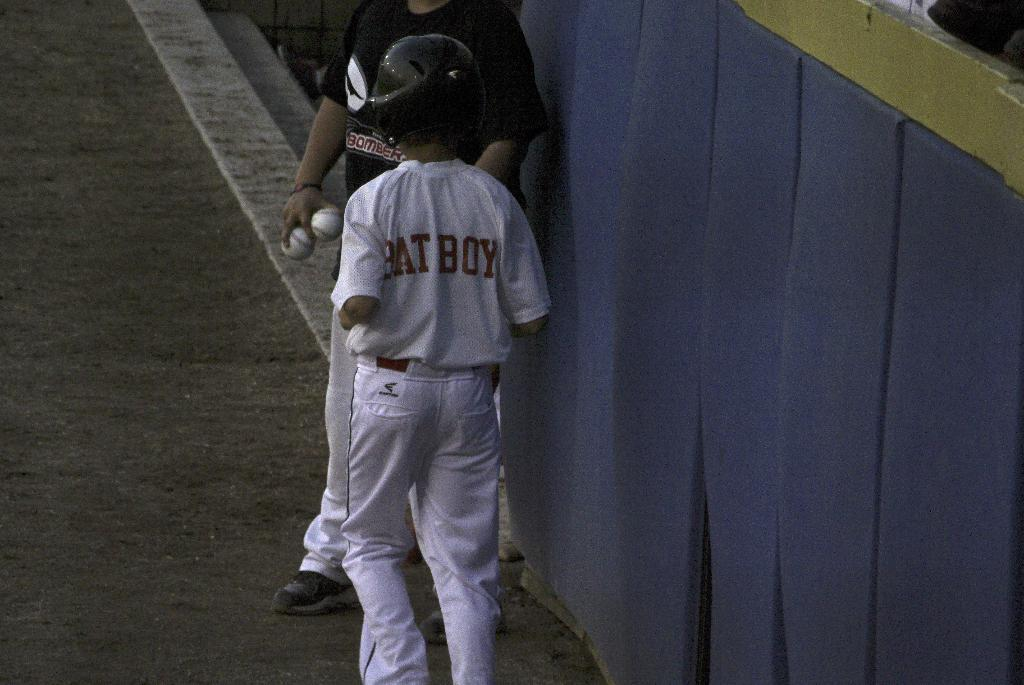<image>
Present a compact description of the photo's key features. a person with the words bat boy on one of their jerseys 